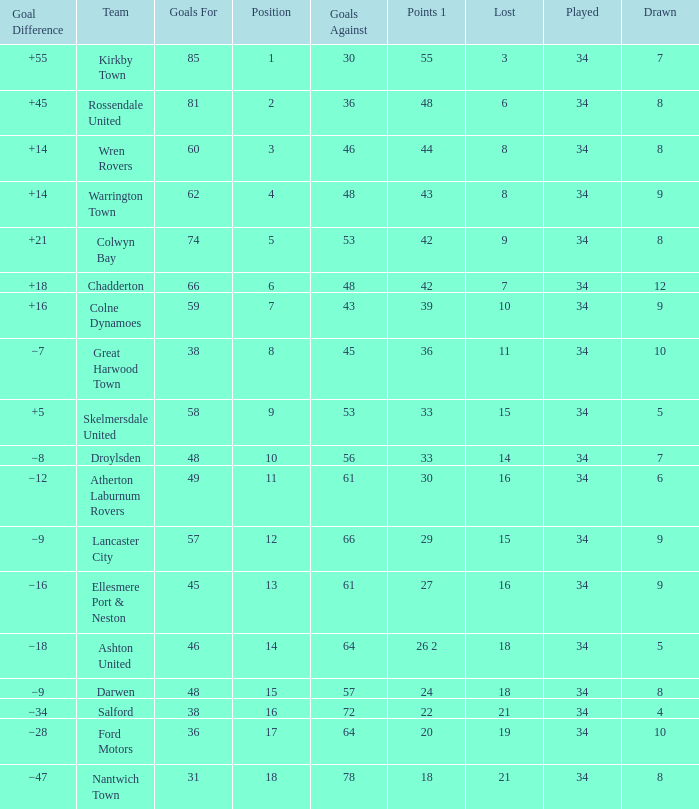What is the total number of positions when there are more than 48 goals against, 1 of 29 points are played, and less than 34 games have been played? 0.0. 